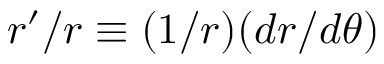Convert formula to latex. <formula><loc_0><loc_0><loc_500><loc_500>r ^ { \prime } / r \equiv ( 1 / r ) ( d r / d \theta )</formula> 